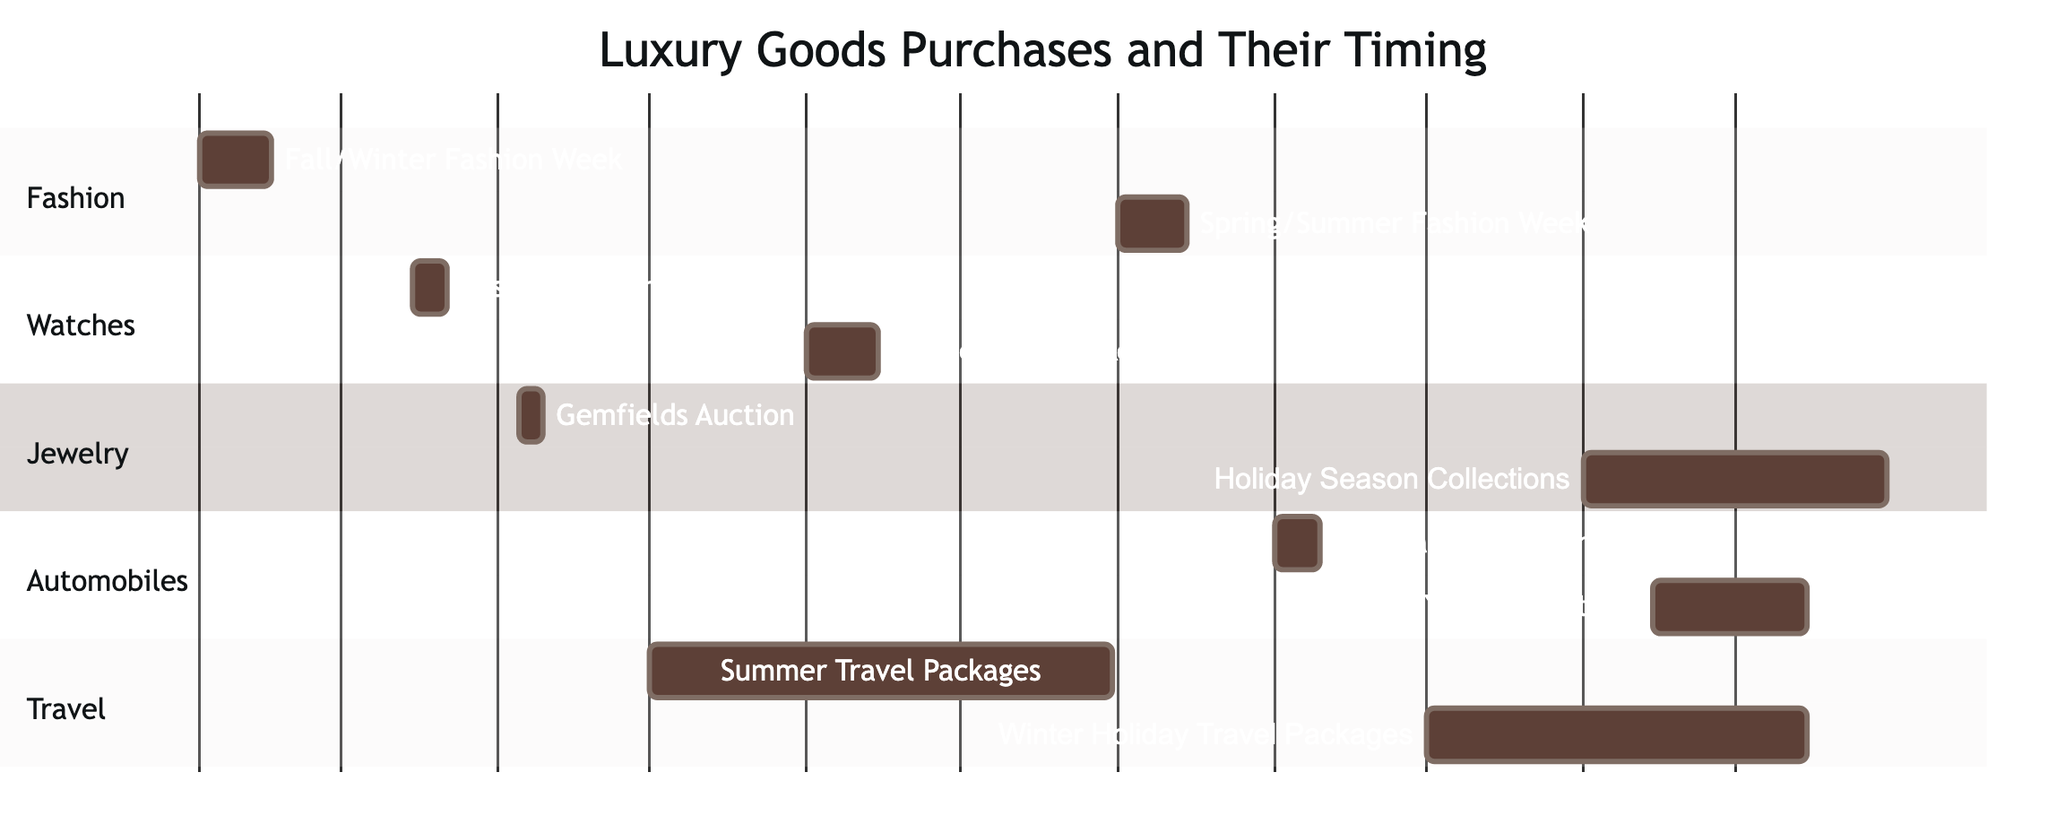What are the subtasks under Luxury Fashion Purchases? The subtasks listed under Luxury Fashion Purchases in the diagram are "Fall/Winter Fashion Week" and "Spring/Summer Fashion Week," as indicated in the section for Fashion.
Answer: Fall/Winter Fashion Week, Spring/Summer Fashion Week When does the Baselworld Exhibition occur? The Baselworld Exhibition is represented in the Watches section of the Gantt Chart and its time frame is indicated as starting on "2023-03-15" and ending on "2023-03-22."
Answer: 2023-03-15 to 2023-03-22 How many tasks are related to Automobile Transactions? There is one task under Automobile Transactions, which consists of two subtasks: "International Motor Show" and "End of Year Promotions." The Gantt Chart shows these details clearly.
Answer: 1 What is the duration of the Holiday Season Exclusive Collections? The Holiday Season Exclusive Collections task under High-End Jewelry Purchases starts on "2023-11-01" and ends on "2023-12-31." To find the duration, we consider these two dates.
Answer: 61 days Which category has the earliest purchase event? The earliest purchase event is "Fall/Winter Fashion Week," which is in the Fashion section, occurring from "2023-02-01" to "2023-02-15." By comparing start dates of all tasks, this is the first one listed.
Answer: Fashion Is there any overlap between Luxury Travel Bookings and Luxury Watches Acquisition? Luxury Travel Bookings have two subtasks: "Summer Travel Packages" (2023-05-01 to 2023-07-31) and "Winter Holiday Travel Packages" (2023-10-01 to 2023-12-15). Luxury Watches Acquisition's subtasks, "Baselworld Exhibition" (2023-03-15 to 2023-03-22) and "Limited Edition Releases" (2023-06-01 to 2023-06-15) overlap with "Summer Travel Packages" during June.
Answer: Yes What is the latest task in the Gantt Chart? To determine the latest task, we check the end dates of all tasks. The latest task listed is "Holiday Season Exclusive Collections," which ends on "2023-12-31," making it the latest event in the diagram.
Answer: Holiday Season Exclusive Collections How many total subtasks are there in the diagram? By counting the subtasks across all main tasks in the diagram, we find that there are a total of 8 subtasks: 2 in Fashion, 2 in Watches, 2 in Jewelry, 2 in Automobiles, and 2 in Travel.
Answer: 10 